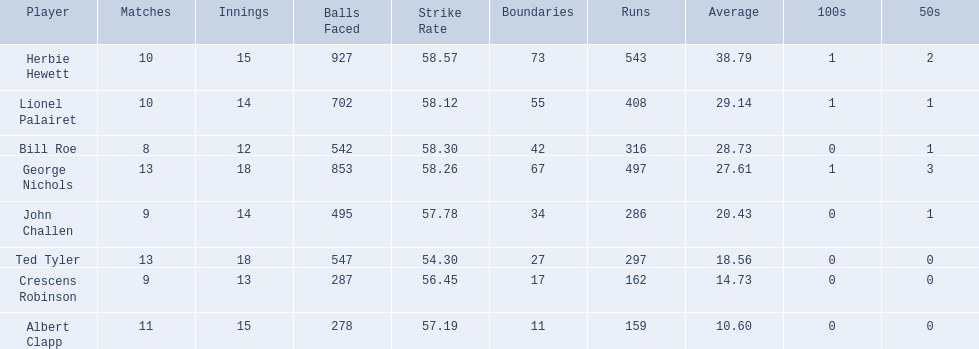Who are all of the players? Herbie Hewett, Lionel Palairet, Bill Roe, George Nichols, John Challen, Ted Tyler, Crescens Robinson, Albert Clapp. How many innings did they play in? 15, 14, 12, 18, 14, 18, 13, 15. Which player was in fewer than 13 innings? Bill Roe. 